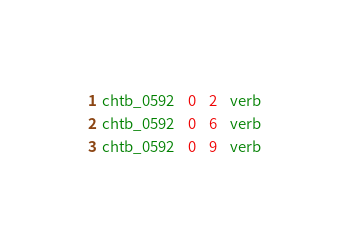<code> <loc_0><loc_0><loc_500><loc_500><_SQL_>chtb_0592	0	2	verb
chtb_0592	0	6	verb
chtb_0592	0	9	verb</code> 